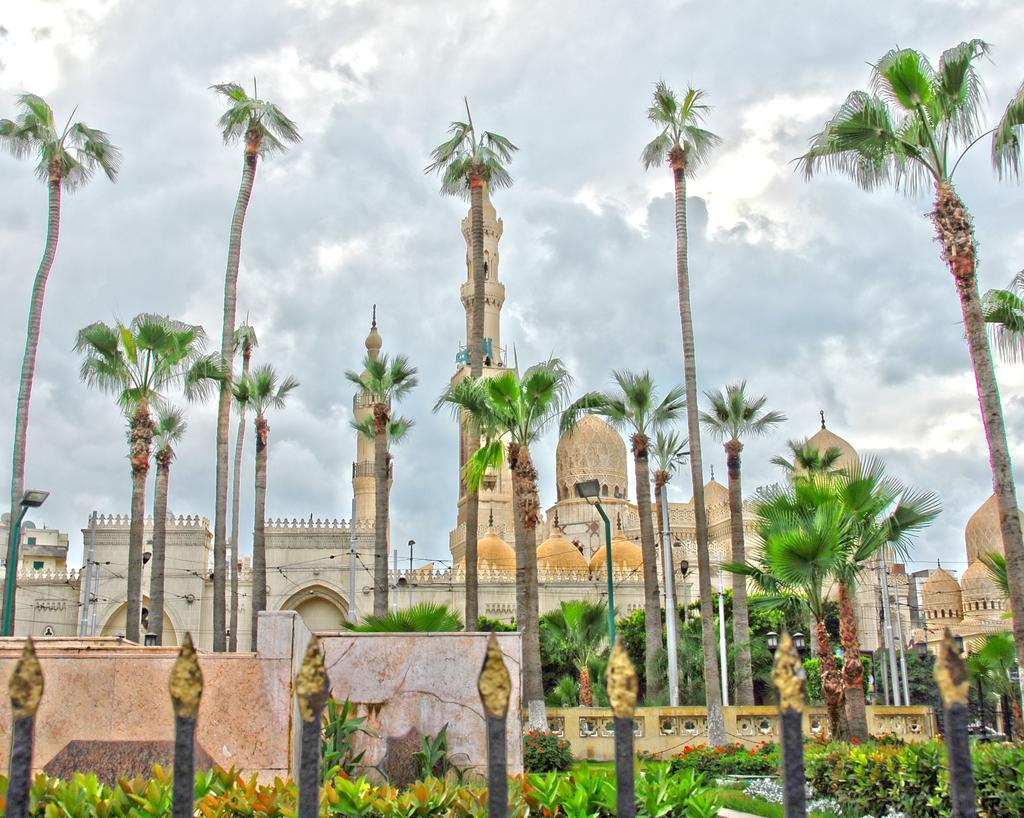What type of structure can be seen in the image? There are iron grills in the image. What type of vegetation is present in the image? There are plants in the image. What is the background of the image composed of? There is a wall in the image, and behind it, there are trees, buildings, and the sky visible. What other objects can be seen in the image? There are poles in the image. What type of cabbage is being used to hold the iron grills in place? There is no cabbage present in the image, and it is not being used to hold the iron grills in place. How does the wrench help the plants grow in the image? There is no wrench present in the image, and it is not involved in the growth of the plants. 